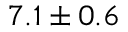Convert formula to latex. <formula><loc_0><loc_0><loc_500><loc_500>7 . 1 \pm 0 . 6</formula> 